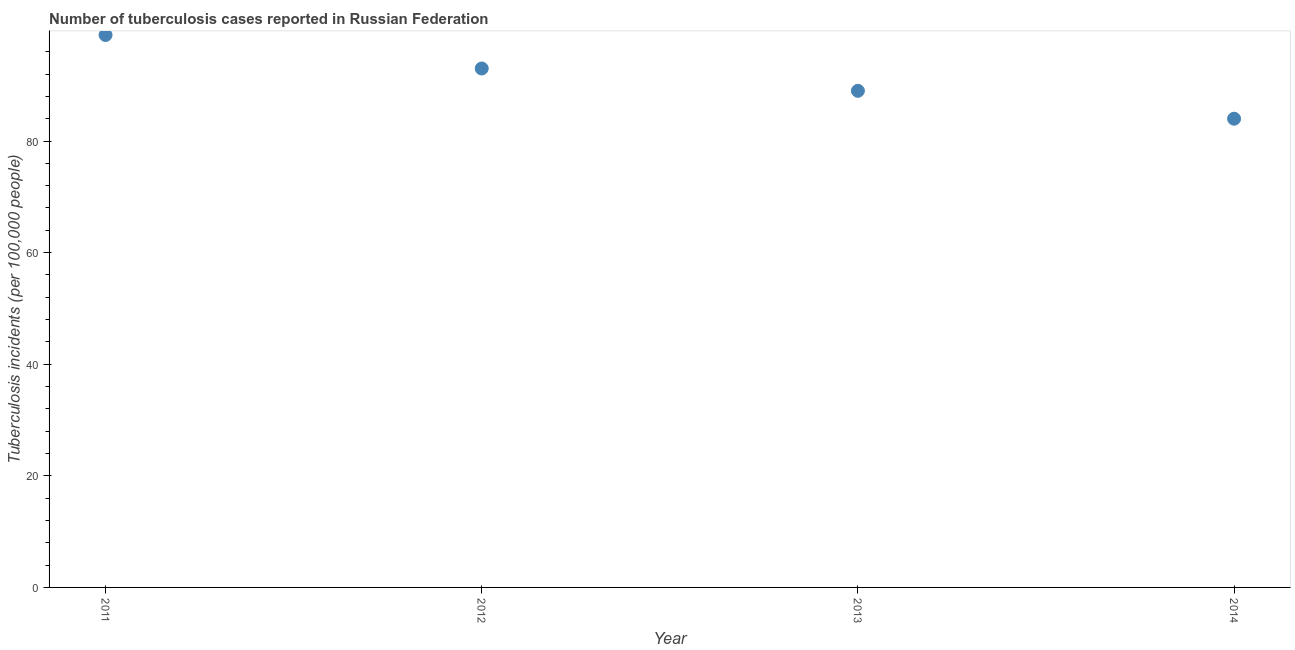What is the number of tuberculosis incidents in 2011?
Keep it short and to the point. 99. Across all years, what is the maximum number of tuberculosis incidents?
Offer a very short reply. 99. Across all years, what is the minimum number of tuberculosis incidents?
Offer a very short reply. 84. In which year was the number of tuberculosis incidents maximum?
Ensure brevity in your answer.  2011. What is the sum of the number of tuberculosis incidents?
Give a very brief answer. 365. What is the difference between the number of tuberculosis incidents in 2011 and 2012?
Offer a terse response. 6. What is the average number of tuberculosis incidents per year?
Your answer should be very brief. 91.25. What is the median number of tuberculosis incidents?
Keep it short and to the point. 91. What is the ratio of the number of tuberculosis incidents in 2011 to that in 2014?
Your answer should be compact. 1.18. What is the difference between the highest and the lowest number of tuberculosis incidents?
Provide a short and direct response. 15. How many years are there in the graph?
Ensure brevity in your answer.  4. What is the difference between two consecutive major ticks on the Y-axis?
Keep it short and to the point. 20. Are the values on the major ticks of Y-axis written in scientific E-notation?
Offer a very short reply. No. What is the title of the graph?
Ensure brevity in your answer.  Number of tuberculosis cases reported in Russian Federation. What is the label or title of the X-axis?
Your answer should be compact. Year. What is the label or title of the Y-axis?
Offer a terse response. Tuberculosis incidents (per 100,0 people). What is the Tuberculosis incidents (per 100,000 people) in 2012?
Your answer should be very brief. 93. What is the Tuberculosis incidents (per 100,000 people) in 2013?
Provide a short and direct response. 89. What is the difference between the Tuberculosis incidents (per 100,000 people) in 2011 and 2014?
Offer a very short reply. 15. What is the difference between the Tuberculosis incidents (per 100,000 people) in 2012 and 2013?
Provide a succinct answer. 4. What is the difference between the Tuberculosis incidents (per 100,000 people) in 2013 and 2014?
Your response must be concise. 5. What is the ratio of the Tuberculosis incidents (per 100,000 people) in 2011 to that in 2012?
Keep it short and to the point. 1.06. What is the ratio of the Tuberculosis incidents (per 100,000 people) in 2011 to that in 2013?
Ensure brevity in your answer.  1.11. What is the ratio of the Tuberculosis incidents (per 100,000 people) in 2011 to that in 2014?
Keep it short and to the point. 1.18. What is the ratio of the Tuberculosis incidents (per 100,000 people) in 2012 to that in 2013?
Your answer should be compact. 1.04. What is the ratio of the Tuberculosis incidents (per 100,000 people) in 2012 to that in 2014?
Your answer should be compact. 1.11. What is the ratio of the Tuberculosis incidents (per 100,000 people) in 2013 to that in 2014?
Your answer should be compact. 1.06. 